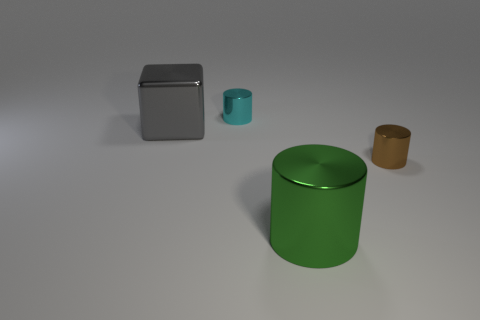Add 2 yellow rubber cubes. How many objects exist? 6 Subtract all cubes. How many objects are left? 3 Add 3 blue matte spheres. How many blue matte spheres exist? 3 Subtract 0 yellow blocks. How many objects are left? 4 Subtract all big objects. Subtract all big blue matte cylinders. How many objects are left? 2 Add 4 tiny brown metallic things. How many tiny brown metallic things are left? 5 